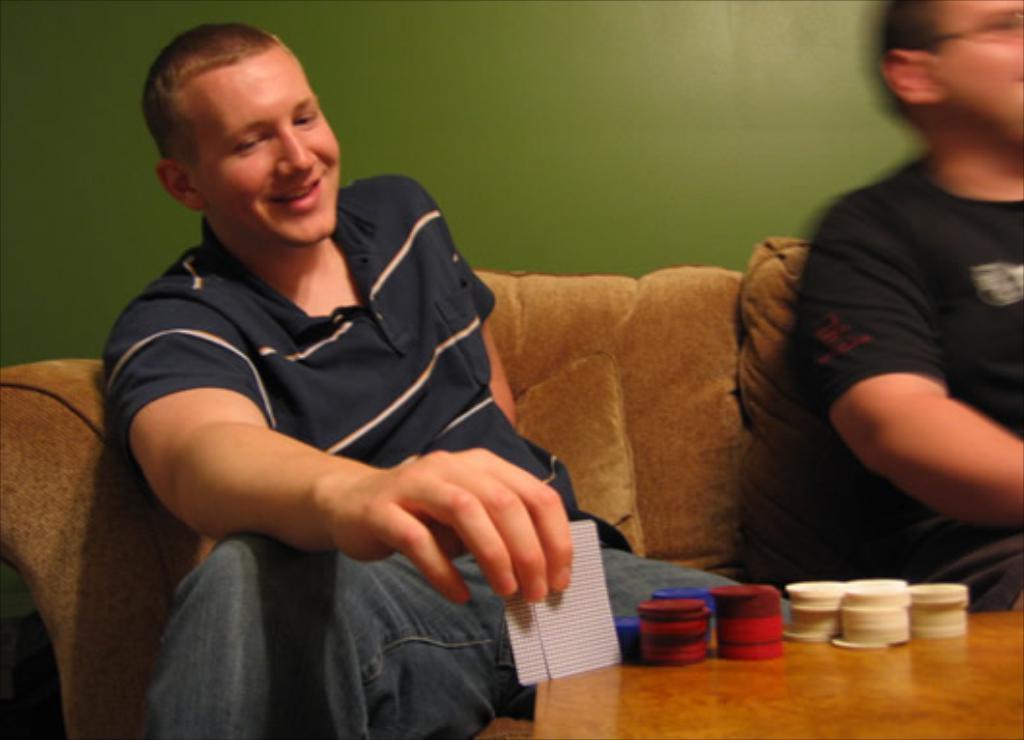How would you summarize this image in a sentence or two? In this image we can see two persons sitting on the sofa, in front of them there are some coins and cards on the table, in the background we can see the wall. 